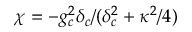<formula> <loc_0><loc_0><loc_500><loc_500>\chi = - g _ { c } ^ { 2 } \delta _ { c } / ( \delta _ { c } ^ { 2 } + \kappa ^ { 2 } / 4 )</formula> 